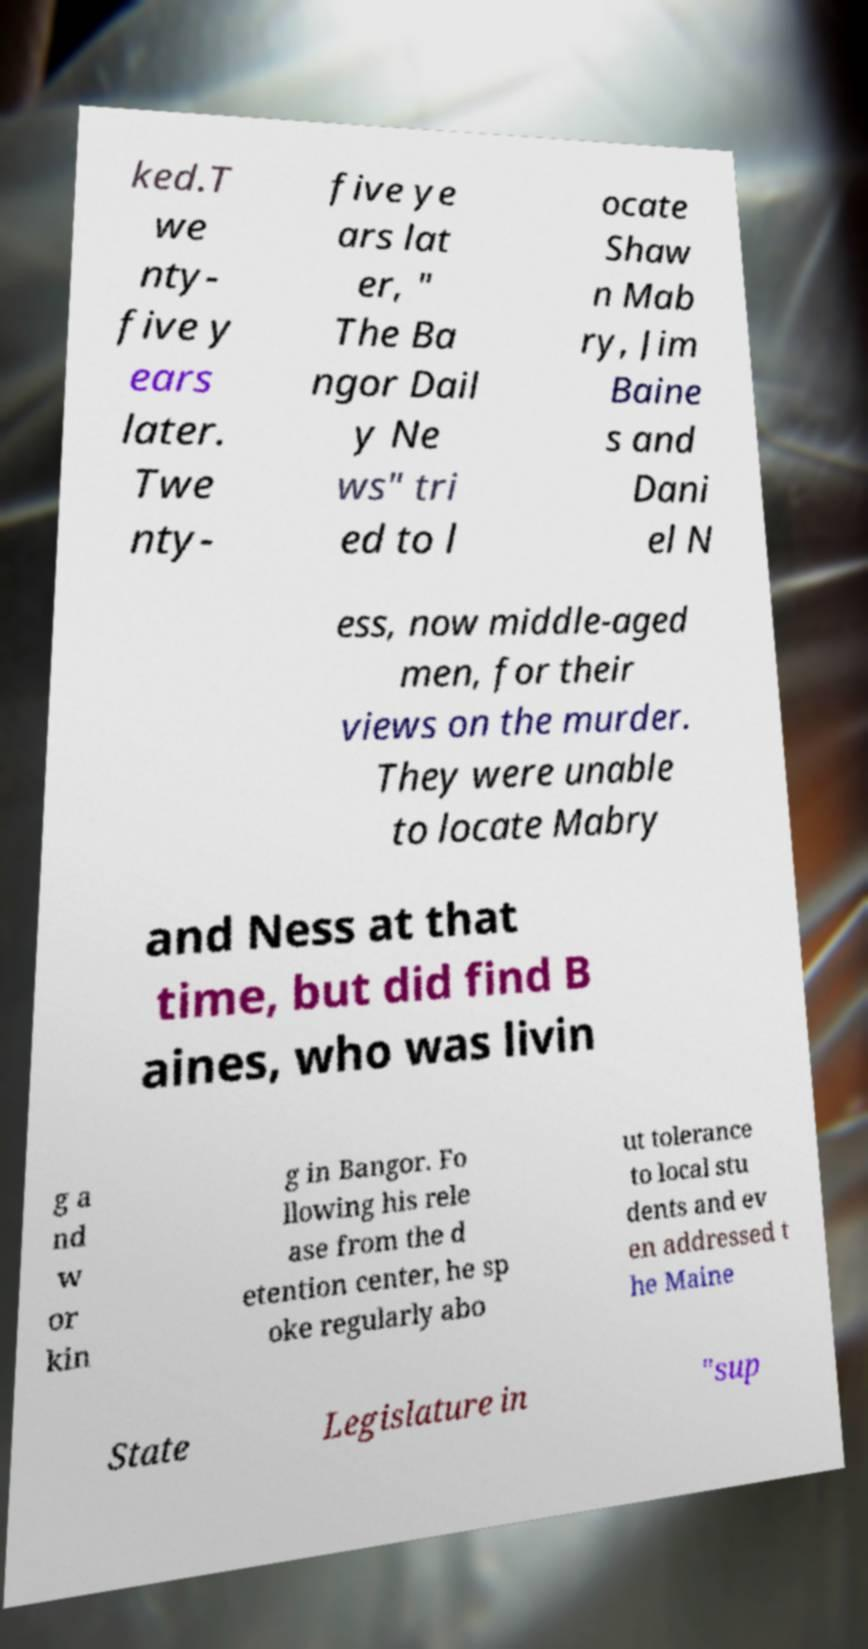Could you assist in decoding the text presented in this image and type it out clearly? ked.T we nty- five y ears later. Twe nty- five ye ars lat er, " The Ba ngor Dail y Ne ws" tri ed to l ocate Shaw n Mab ry, Jim Baine s and Dani el N ess, now middle-aged men, for their views on the murder. They were unable to locate Mabry and Ness at that time, but did find B aines, who was livin g a nd w or kin g in Bangor. Fo llowing his rele ase from the d etention center, he sp oke regularly abo ut tolerance to local stu dents and ev en addressed t he Maine State Legislature in "sup 